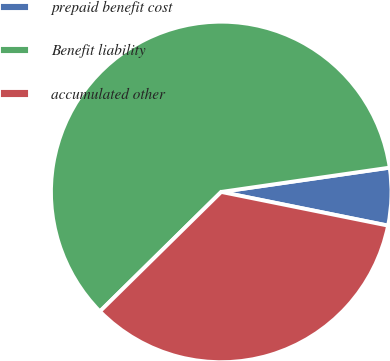<chart> <loc_0><loc_0><loc_500><loc_500><pie_chart><fcel>prepaid benefit cost<fcel>Benefit liability<fcel>accumulated other<nl><fcel>5.45%<fcel>60.1%<fcel>34.45%<nl></chart> 